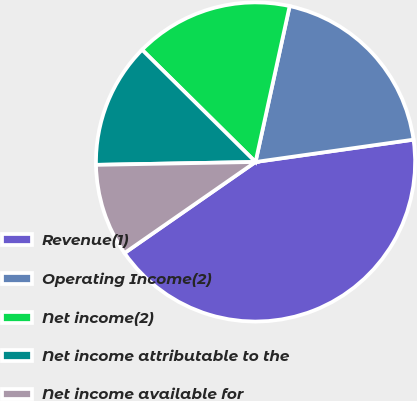Convert chart. <chart><loc_0><loc_0><loc_500><loc_500><pie_chart><fcel>Revenue(1)<fcel>Operating Income(2)<fcel>Net income(2)<fcel>Net income attributable to the<fcel>Net income available for<nl><fcel>42.57%<fcel>19.34%<fcel>16.02%<fcel>12.7%<fcel>9.38%<nl></chart> 